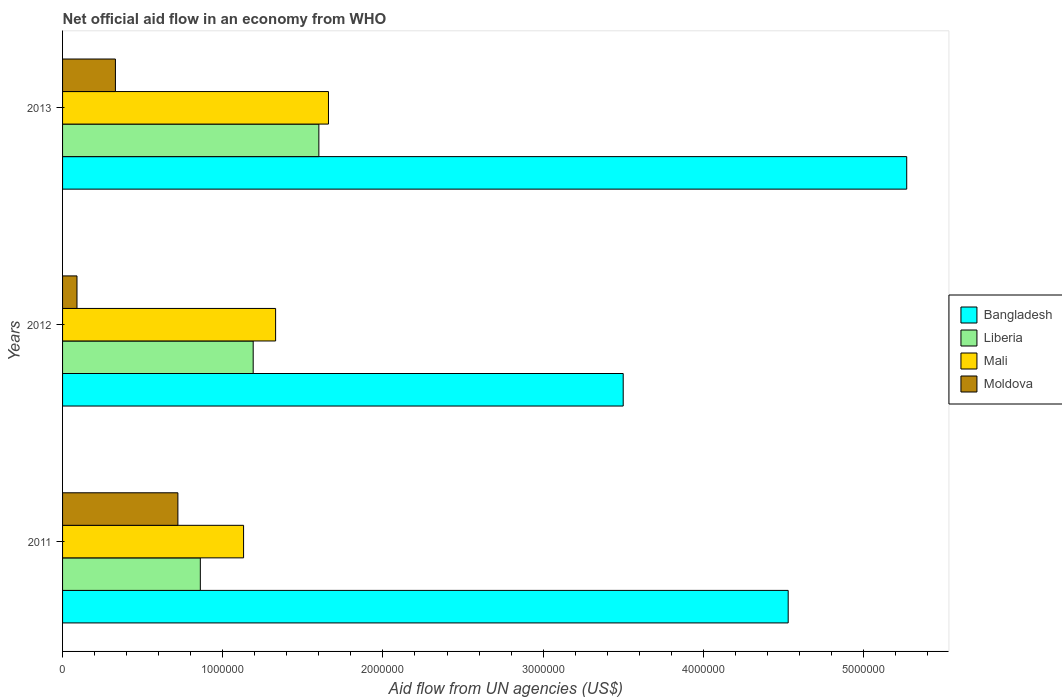How many groups of bars are there?
Your answer should be compact. 3. Are the number of bars per tick equal to the number of legend labels?
Keep it short and to the point. Yes. How many bars are there on the 3rd tick from the top?
Ensure brevity in your answer.  4. How many bars are there on the 1st tick from the bottom?
Offer a terse response. 4. What is the label of the 2nd group of bars from the top?
Offer a terse response. 2012. What is the net official aid flow in Moldova in 2011?
Provide a short and direct response. 7.20e+05. Across all years, what is the maximum net official aid flow in Liberia?
Your response must be concise. 1.60e+06. Across all years, what is the minimum net official aid flow in Mali?
Give a very brief answer. 1.13e+06. What is the total net official aid flow in Mali in the graph?
Offer a very short reply. 4.12e+06. What is the difference between the net official aid flow in Moldova in 2011 and that in 2013?
Give a very brief answer. 3.90e+05. What is the difference between the net official aid flow in Mali in 2013 and the net official aid flow in Bangladesh in 2012?
Ensure brevity in your answer.  -1.84e+06. What is the average net official aid flow in Liberia per year?
Make the answer very short. 1.22e+06. In the year 2012, what is the difference between the net official aid flow in Moldova and net official aid flow in Bangladesh?
Offer a terse response. -3.41e+06. What is the ratio of the net official aid flow in Bangladesh in 2011 to that in 2013?
Your response must be concise. 0.86. Is the difference between the net official aid flow in Moldova in 2012 and 2013 greater than the difference between the net official aid flow in Bangladesh in 2012 and 2013?
Make the answer very short. Yes. What is the difference between the highest and the second highest net official aid flow in Liberia?
Give a very brief answer. 4.10e+05. What is the difference between the highest and the lowest net official aid flow in Bangladesh?
Offer a very short reply. 1.77e+06. In how many years, is the net official aid flow in Liberia greater than the average net official aid flow in Liberia taken over all years?
Your response must be concise. 1. Is it the case that in every year, the sum of the net official aid flow in Moldova and net official aid flow in Bangladesh is greater than the sum of net official aid flow in Mali and net official aid flow in Liberia?
Your response must be concise. No. What does the 2nd bar from the top in 2013 represents?
Your response must be concise. Mali. What does the 2nd bar from the bottom in 2012 represents?
Your answer should be compact. Liberia. Is it the case that in every year, the sum of the net official aid flow in Bangladesh and net official aid flow in Liberia is greater than the net official aid flow in Mali?
Provide a succinct answer. Yes. Are the values on the major ticks of X-axis written in scientific E-notation?
Offer a terse response. No. Where does the legend appear in the graph?
Provide a succinct answer. Center right. How are the legend labels stacked?
Give a very brief answer. Vertical. What is the title of the graph?
Your answer should be very brief. Net official aid flow in an economy from WHO. Does "Sweden" appear as one of the legend labels in the graph?
Give a very brief answer. No. What is the label or title of the X-axis?
Offer a very short reply. Aid flow from UN agencies (US$). What is the Aid flow from UN agencies (US$) in Bangladesh in 2011?
Make the answer very short. 4.53e+06. What is the Aid flow from UN agencies (US$) of Liberia in 2011?
Keep it short and to the point. 8.60e+05. What is the Aid flow from UN agencies (US$) of Mali in 2011?
Ensure brevity in your answer.  1.13e+06. What is the Aid flow from UN agencies (US$) in Moldova in 2011?
Make the answer very short. 7.20e+05. What is the Aid flow from UN agencies (US$) of Bangladesh in 2012?
Give a very brief answer. 3.50e+06. What is the Aid flow from UN agencies (US$) in Liberia in 2012?
Your answer should be very brief. 1.19e+06. What is the Aid flow from UN agencies (US$) of Mali in 2012?
Your answer should be very brief. 1.33e+06. What is the Aid flow from UN agencies (US$) of Bangladesh in 2013?
Make the answer very short. 5.27e+06. What is the Aid flow from UN agencies (US$) of Liberia in 2013?
Give a very brief answer. 1.60e+06. What is the Aid flow from UN agencies (US$) in Mali in 2013?
Provide a succinct answer. 1.66e+06. Across all years, what is the maximum Aid flow from UN agencies (US$) in Bangladesh?
Your response must be concise. 5.27e+06. Across all years, what is the maximum Aid flow from UN agencies (US$) of Liberia?
Give a very brief answer. 1.60e+06. Across all years, what is the maximum Aid flow from UN agencies (US$) in Mali?
Provide a succinct answer. 1.66e+06. Across all years, what is the maximum Aid flow from UN agencies (US$) of Moldova?
Make the answer very short. 7.20e+05. Across all years, what is the minimum Aid flow from UN agencies (US$) of Bangladesh?
Your answer should be very brief. 3.50e+06. Across all years, what is the minimum Aid flow from UN agencies (US$) of Liberia?
Provide a short and direct response. 8.60e+05. Across all years, what is the minimum Aid flow from UN agencies (US$) of Mali?
Keep it short and to the point. 1.13e+06. Across all years, what is the minimum Aid flow from UN agencies (US$) in Moldova?
Your answer should be compact. 9.00e+04. What is the total Aid flow from UN agencies (US$) of Bangladesh in the graph?
Your answer should be very brief. 1.33e+07. What is the total Aid flow from UN agencies (US$) of Liberia in the graph?
Ensure brevity in your answer.  3.65e+06. What is the total Aid flow from UN agencies (US$) of Mali in the graph?
Make the answer very short. 4.12e+06. What is the total Aid flow from UN agencies (US$) of Moldova in the graph?
Provide a short and direct response. 1.14e+06. What is the difference between the Aid flow from UN agencies (US$) of Bangladesh in 2011 and that in 2012?
Ensure brevity in your answer.  1.03e+06. What is the difference between the Aid flow from UN agencies (US$) of Liberia in 2011 and that in 2012?
Make the answer very short. -3.30e+05. What is the difference between the Aid flow from UN agencies (US$) in Moldova in 2011 and that in 2012?
Make the answer very short. 6.30e+05. What is the difference between the Aid flow from UN agencies (US$) in Bangladesh in 2011 and that in 2013?
Provide a succinct answer. -7.40e+05. What is the difference between the Aid flow from UN agencies (US$) in Liberia in 2011 and that in 2013?
Your answer should be very brief. -7.40e+05. What is the difference between the Aid flow from UN agencies (US$) in Mali in 2011 and that in 2013?
Ensure brevity in your answer.  -5.30e+05. What is the difference between the Aid flow from UN agencies (US$) in Moldova in 2011 and that in 2013?
Your response must be concise. 3.90e+05. What is the difference between the Aid flow from UN agencies (US$) of Bangladesh in 2012 and that in 2013?
Offer a terse response. -1.77e+06. What is the difference between the Aid flow from UN agencies (US$) in Liberia in 2012 and that in 2013?
Your response must be concise. -4.10e+05. What is the difference between the Aid flow from UN agencies (US$) in Mali in 2012 and that in 2013?
Ensure brevity in your answer.  -3.30e+05. What is the difference between the Aid flow from UN agencies (US$) in Moldova in 2012 and that in 2013?
Your response must be concise. -2.40e+05. What is the difference between the Aid flow from UN agencies (US$) in Bangladesh in 2011 and the Aid flow from UN agencies (US$) in Liberia in 2012?
Your answer should be very brief. 3.34e+06. What is the difference between the Aid flow from UN agencies (US$) in Bangladesh in 2011 and the Aid flow from UN agencies (US$) in Mali in 2012?
Provide a short and direct response. 3.20e+06. What is the difference between the Aid flow from UN agencies (US$) of Bangladesh in 2011 and the Aid flow from UN agencies (US$) of Moldova in 2012?
Offer a terse response. 4.44e+06. What is the difference between the Aid flow from UN agencies (US$) in Liberia in 2011 and the Aid flow from UN agencies (US$) in Mali in 2012?
Offer a terse response. -4.70e+05. What is the difference between the Aid flow from UN agencies (US$) of Liberia in 2011 and the Aid flow from UN agencies (US$) of Moldova in 2012?
Provide a short and direct response. 7.70e+05. What is the difference between the Aid flow from UN agencies (US$) of Mali in 2011 and the Aid flow from UN agencies (US$) of Moldova in 2012?
Provide a succinct answer. 1.04e+06. What is the difference between the Aid flow from UN agencies (US$) in Bangladesh in 2011 and the Aid flow from UN agencies (US$) in Liberia in 2013?
Provide a short and direct response. 2.93e+06. What is the difference between the Aid flow from UN agencies (US$) in Bangladesh in 2011 and the Aid flow from UN agencies (US$) in Mali in 2013?
Keep it short and to the point. 2.87e+06. What is the difference between the Aid flow from UN agencies (US$) of Bangladesh in 2011 and the Aid flow from UN agencies (US$) of Moldova in 2013?
Your answer should be compact. 4.20e+06. What is the difference between the Aid flow from UN agencies (US$) of Liberia in 2011 and the Aid flow from UN agencies (US$) of Mali in 2013?
Keep it short and to the point. -8.00e+05. What is the difference between the Aid flow from UN agencies (US$) in Liberia in 2011 and the Aid flow from UN agencies (US$) in Moldova in 2013?
Offer a very short reply. 5.30e+05. What is the difference between the Aid flow from UN agencies (US$) in Bangladesh in 2012 and the Aid flow from UN agencies (US$) in Liberia in 2013?
Offer a terse response. 1.90e+06. What is the difference between the Aid flow from UN agencies (US$) of Bangladesh in 2012 and the Aid flow from UN agencies (US$) of Mali in 2013?
Offer a terse response. 1.84e+06. What is the difference between the Aid flow from UN agencies (US$) of Bangladesh in 2012 and the Aid flow from UN agencies (US$) of Moldova in 2013?
Provide a short and direct response. 3.17e+06. What is the difference between the Aid flow from UN agencies (US$) in Liberia in 2012 and the Aid flow from UN agencies (US$) in Mali in 2013?
Your answer should be very brief. -4.70e+05. What is the difference between the Aid flow from UN agencies (US$) of Liberia in 2012 and the Aid flow from UN agencies (US$) of Moldova in 2013?
Ensure brevity in your answer.  8.60e+05. What is the average Aid flow from UN agencies (US$) of Bangladesh per year?
Offer a terse response. 4.43e+06. What is the average Aid flow from UN agencies (US$) in Liberia per year?
Your response must be concise. 1.22e+06. What is the average Aid flow from UN agencies (US$) of Mali per year?
Keep it short and to the point. 1.37e+06. What is the average Aid flow from UN agencies (US$) of Moldova per year?
Your answer should be very brief. 3.80e+05. In the year 2011, what is the difference between the Aid flow from UN agencies (US$) of Bangladesh and Aid flow from UN agencies (US$) of Liberia?
Provide a succinct answer. 3.67e+06. In the year 2011, what is the difference between the Aid flow from UN agencies (US$) in Bangladesh and Aid flow from UN agencies (US$) in Mali?
Provide a succinct answer. 3.40e+06. In the year 2011, what is the difference between the Aid flow from UN agencies (US$) of Bangladesh and Aid flow from UN agencies (US$) of Moldova?
Make the answer very short. 3.81e+06. In the year 2011, what is the difference between the Aid flow from UN agencies (US$) in Liberia and Aid flow from UN agencies (US$) in Moldova?
Keep it short and to the point. 1.40e+05. In the year 2011, what is the difference between the Aid flow from UN agencies (US$) of Mali and Aid flow from UN agencies (US$) of Moldova?
Keep it short and to the point. 4.10e+05. In the year 2012, what is the difference between the Aid flow from UN agencies (US$) in Bangladesh and Aid flow from UN agencies (US$) in Liberia?
Your answer should be very brief. 2.31e+06. In the year 2012, what is the difference between the Aid flow from UN agencies (US$) in Bangladesh and Aid flow from UN agencies (US$) in Mali?
Offer a terse response. 2.17e+06. In the year 2012, what is the difference between the Aid flow from UN agencies (US$) in Bangladesh and Aid flow from UN agencies (US$) in Moldova?
Your answer should be very brief. 3.41e+06. In the year 2012, what is the difference between the Aid flow from UN agencies (US$) in Liberia and Aid flow from UN agencies (US$) in Mali?
Your answer should be compact. -1.40e+05. In the year 2012, what is the difference between the Aid flow from UN agencies (US$) of Liberia and Aid flow from UN agencies (US$) of Moldova?
Ensure brevity in your answer.  1.10e+06. In the year 2012, what is the difference between the Aid flow from UN agencies (US$) of Mali and Aid flow from UN agencies (US$) of Moldova?
Ensure brevity in your answer.  1.24e+06. In the year 2013, what is the difference between the Aid flow from UN agencies (US$) of Bangladesh and Aid flow from UN agencies (US$) of Liberia?
Provide a succinct answer. 3.67e+06. In the year 2013, what is the difference between the Aid flow from UN agencies (US$) in Bangladesh and Aid flow from UN agencies (US$) in Mali?
Your response must be concise. 3.61e+06. In the year 2013, what is the difference between the Aid flow from UN agencies (US$) in Bangladesh and Aid flow from UN agencies (US$) in Moldova?
Make the answer very short. 4.94e+06. In the year 2013, what is the difference between the Aid flow from UN agencies (US$) of Liberia and Aid flow from UN agencies (US$) of Moldova?
Your response must be concise. 1.27e+06. In the year 2013, what is the difference between the Aid flow from UN agencies (US$) in Mali and Aid flow from UN agencies (US$) in Moldova?
Make the answer very short. 1.33e+06. What is the ratio of the Aid flow from UN agencies (US$) of Bangladesh in 2011 to that in 2012?
Your answer should be compact. 1.29. What is the ratio of the Aid flow from UN agencies (US$) of Liberia in 2011 to that in 2012?
Give a very brief answer. 0.72. What is the ratio of the Aid flow from UN agencies (US$) of Mali in 2011 to that in 2012?
Keep it short and to the point. 0.85. What is the ratio of the Aid flow from UN agencies (US$) of Bangladesh in 2011 to that in 2013?
Keep it short and to the point. 0.86. What is the ratio of the Aid flow from UN agencies (US$) in Liberia in 2011 to that in 2013?
Make the answer very short. 0.54. What is the ratio of the Aid flow from UN agencies (US$) of Mali in 2011 to that in 2013?
Keep it short and to the point. 0.68. What is the ratio of the Aid flow from UN agencies (US$) of Moldova in 2011 to that in 2013?
Your answer should be compact. 2.18. What is the ratio of the Aid flow from UN agencies (US$) in Bangladesh in 2012 to that in 2013?
Offer a terse response. 0.66. What is the ratio of the Aid flow from UN agencies (US$) in Liberia in 2012 to that in 2013?
Ensure brevity in your answer.  0.74. What is the ratio of the Aid flow from UN agencies (US$) in Mali in 2012 to that in 2013?
Provide a succinct answer. 0.8. What is the ratio of the Aid flow from UN agencies (US$) of Moldova in 2012 to that in 2013?
Your response must be concise. 0.27. What is the difference between the highest and the second highest Aid flow from UN agencies (US$) of Bangladesh?
Your answer should be compact. 7.40e+05. What is the difference between the highest and the second highest Aid flow from UN agencies (US$) of Mali?
Your response must be concise. 3.30e+05. What is the difference between the highest and the lowest Aid flow from UN agencies (US$) of Bangladesh?
Your answer should be compact. 1.77e+06. What is the difference between the highest and the lowest Aid flow from UN agencies (US$) of Liberia?
Your answer should be compact. 7.40e+05. What is the difference between the highest and the lowest Aid flow from UN agencies (US$) of Mali?
Make the answer very short. 5.30e+05. What is the difference between the highest and the lowest Aid flow from UN agencies (US$) of Moldova?
Ensure brevity in your answer.  6.30e+05. 